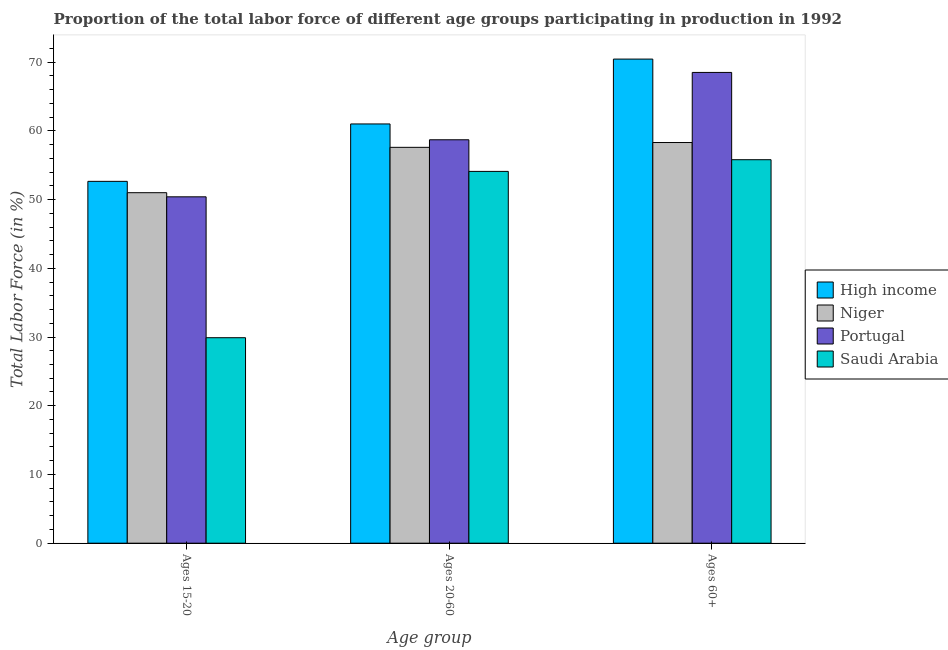How many groups of bars are there?
Keep it short and to the point. 3. How many bars are there on the 2nd tick from the right?
Your response must be concise. 4. What is the label of the 3rd group of bars from the left?
Provide a succinct answer. Ages 60+. What is the percentage of labor force above age 60 in Saudi Arabia?
Offer a terse response. 55.8. Across all countries, what is the maximum percentage of labor force within the age group 15-20?
Give a very brief answer. 52.65. Across all countries, what is the minimum percentage of labor force within the age group 20-60?
Your response must be concise. 54.1. In which country was the percentage of labor force within the age group 20-60 maximum?
Your response must be concise. High income. In which country was the percentage of labor force above age 60 minimum?
Offer a very short reply. Saudi Arabia. What is the total percentage of labor force within the age group 20-60 in the graph?
Offer a very short reply. 231.4. What is the difference between the percentage of labor force within the age group 20-60 in Portugal and that in Saudi Arabia?
Provide a succinct answer. 4.6. What is the difference between the percentage of labor force above age 60 in Saudi Arabia and the percentage of labor force within the age group 20-60 in Portugal?
Your answer should be very brief. -2.9. What is the average percentage of labor force within the age group 20-60 per country?
Offer a terse response. 57.85. What is the difference between the percentage of labor force within the age group 15-20 and percentage of labor force within the age group 20-60 in High income?
Make the answer very short. -8.35. What is the ratio of the percentage of labor force within the age group 15-20 in Niger to that in High income?
Provide a succinct answer. 0.97. Is the percentage of labor force within the age group 20-60 in Niger less than that in High income?
Offer a terse response. Yes. Is the difference between the percentage of labor force within the age group 20-60 in Saudi Arabia and Portugal greater than the difference between the percentage of labor force above age 60 in Saudi Arabia and Portugal?
Your response must be concise. Yes. What is the difference between the highest and the second highest percentage of labor force within the age group 15-20?
Make the answer very short. 1.65. What is the difference between the highest and the lowest percentage of labor force within the age group 15-20?
Offer a terse response. 22.75. Is the sum of the percentage of labor force within the age group 15-20 in Niger and Portugal greater than the maximum percentage of labor force above age 60 across all countries?
Ensure brevity in your answer.  Yes. What does the 1st bar from the left in Ages 20-60 represents?
Your answer should be very brief. High income. Are all the bars in the graph horizontal?
Keep it short and to the point. No. How many countries are there in the graph?
Provide a succinct answer. 4. Does the graph contain grids?
Provide a short and direct response. No. Where does the legend appear in the graph?
Offer a terse response. Center right. How many legend labels are there?
Offer a terse response. 4. What is the title of the graph?
Ensure brevity in your answer.  Proportion of the total labor force of different age groups participating in production in 1992. What is the label or title of the X-axis?
Provide a short and direct response. Age group. What is the Total Labor Force (in %) of High income in Ages 15-20?
Give a very brief answer. 52.65. What is the Total Labor Force (in %) in Portugal in Ages 15-20?
Offer a terse response. 50.4. What is the Total Labor Force (in %) of Saudi Arabia in Ages 15-20?
Provide a succinct answer. 29.9. What is the Total Labor Force (in %) in High income in Ages 20-60?
Provide a succinct answer. 61. What is the Total Labor Force (in %) of Niger in Ages 20-60?
Provide a succinct answer. 57.6. What is the Total Labor Force (in %) of Portugal in Ages 20-60?
Ensure brevity in your answer.  58.7. What is the Total Labor Force (in %) in Saudi Arabia in Ages 20-60?
Your answer should be compact. 54.1. What is the Total Labor Force (in %) of High income in Ages 60+?
Offer a very short reply. 70.44. What is the Total Labor Force (in %) of Niger in Ages 60+?
Your response must be concise. 58.3. What is the Total Labor Force (in %) of Portugal in Ages 60+?
Offer a terse response. 68.5. What is the Total Labor Force (in %) of Saudi Arabia in Ages 60+?
Keep it short and to the point. 55.8. Across all Age group, what is the maximum Total Labor Force (in %) in High income?
Your response must be concise. 70.44. Across all Age group, what is the maximum Total Labor Force (in %) of Niger?
Your answer should be very brief. 58.3. Across all Age group, what is the maximum Total Labor Force (in %) in Portugal?
Offer a terse response. 68.5. Across all Age group, what is the maximum Total Labor Force (in %) of Saudi Arabia?
Ensure brevity in your answer.  55.8. Across all Age group, what is the minimum Total Labor Force (in %) in High income?
Provide a short and direct response. 52.65. Across all Age group, what is the minimum Total Labor Force (in %) in Portugal?
Give a very brief answer. 50.4. Across all Age group, what is the minimum Total Labor Force (in %) in Saudi Arabia?
Ensure brevity in your answer.  29.9. What is the total Total Labor Force (in %) of High income in the graph?
Offer a very short reply. 184.09. What is the total Total Labor Force (in %) in Niger in the graph?
Your answer should be compact. 166.9. What is the total Total Labor Force (in %) of Portugal in the graph?
Your answer should be compact. 177.6. What is the total Total Labor Force (in %) of Saudi Arabia in the graph?
Give a very brief answer. 139.8. What is the difference between the Total Labor Force (in %) of High income in Ages 15-20 and that in Ages 20-60?
Offer a very short reply. -8.35. What is the difference between the Total Labor Force (in %) in Niger in Ages 15-20 and that in Ages 20-60?
Provide a short and direct response. -6.6. What is the difference between the Total Labor Force (in %) of Portugal in Ages 15-20 and that in Ages 20-60?
Ensure brevity in your answer.  -8.3. What is the difference between the Total Labor Force (in %) of Saudi Arabia in Ages 15-20 and that in Ages 20-60?
Your answer should be very brief. -24.2. What is the difference between the Total Labor Force (in %) of High income in Ages 15-20 and that in Ages 60+?
Ensure brevity in your answer.  -17.79. What is the difference between the Total Labor Force (in %) in Niger in Ages 15-20 and that in Ages 60+?
Provide a succinct answer. -7.3. What is the difference between the Total Labor Force (in %) in Portugal in Ages 15-20 and that in Ages 60+?
Your answer should be compact. -18.1. What is the difference between the Total Labor Force (in %) in Saudi Arabia in Ages 15-20 and that in Ages 60+?
Offer a terse response. -25.9. What is the difference between the Total Labor Force (in %) in High income in Ages 20-60 and that in Ages 60+?
Your answer should be very brief. -9.44. What is the difference between the Total Labor Force (in %) of Niger in Ages 20-60 and that in Ages 60+?
Offer a very short reply. -0.7. What is the difference between the Total Labor Force (in %) in Portugal in Ages 20-60 and that in Ages 60+?
Provide a short and direct response. -9.8. What is the difference between the Total Labor Force (in %) of High income in Ages 15-20 and the Total Labor Force (in %) of Niger in Ages 20-60?
Your response must be concise. -4.95. What is the difference between the Total Labor Force (in %) in High income in Ages 15-20 and the Total Labor Force (in %) in Portugal in Ages 20-60?
Your response must be concise. -6.05. What is the difference between the Total Labor Force (in %) of High income in Ages 15-20 and the Total Labor Force (in %) of Saudi Arabia in Ages 20-60?
Ensure brevity in your answer.  -1.45. What is the difference between the Total Labor Force (in %) of Niger in Ages 15-20 and the Total Labor Force (in %) of Portugal in Ages 20-60?
Your answer should be compact. -7.7. What is the difference between the Total Labor Force (in %) in Portugal in Ages 15-20 and the Total Labor Force (in %) in Saudi Arabia in Ages 20-60?
Your response must be concise. -3.7. What is the difference between the Total Labor Force (in %) in High income in Ages 15-20 and the Total Labor Force (in %) in Niger in Ages 60+?
Give a very brief answer. -5.65. What is the difference between the Total Labor Force (in %) of High income in Ages 15-20 and the Total Labor Force (in %) of Portugal in Ages 60+?
Provide a short and direct response. -15.85. What is the difference between the Total Labor Force (in %) of High income in Ages 15-20 and the Total Labor Force (in %) of Saudi Arabia in Ages 60+?
Offer a terse response. -3.15. What is the difference between the Total Labor Force (in %) in Niger in Ages 15-20 and the Total Labor Force (in %) in Portugal in Ages 60+?
Keep it short and to the point. -17.5. What is the difference between the Total Labor Force (in %) of Niger in Ages 15-20 and the Total Labor Force (in %) of Saudi Arabia in Ages 60+?
Offer a very short reply. -4.8. What is the difference between the Total Labor Force (in %) in High income in Ages 20-60 and the Total Labor Force (in %) in Niger in Ages 60+?
Your answer should be compact. 2.7. What is the difference between the Total Labor Force (in %) in High income in Ages 20-60 and the Total Labor Force (in %) in Portugal in Ages 60+?
Your response must be concise. -7.5. What is the difference between the Total Labor Force (in %) in High income in Ages 20-60 and the Total Labor Force (in %) in Saudi Arabia in Ages 60+?
Ensure brevity in your answer.  5.2. What is the difference between the Total Labor Force (in %) in Niger in Ages 20-60 and the Total Labor Force (in %) in Portugal in Ages 60+?
Offer a very short reply. -10.9. What is the difference between the Total Labor Force (in %) in Portugal in Ages 20-60 and the Total Labor Force (in %) in Saudi Arabia in Ages 60+?
Your response must be concise. 2.9. What is the average Total Labor Force (in %) of High income per Age group?
Offer a terse response. 61.36. What is the average Total Labor Force (in %) in Niger per Age group?
Give a very brief answer. 55.63. What is the average Total Labor Force (in %) of Portugal per Age group?
Provide a short and direct response. 59.2. What is the average Total Labor Force (in %) of Saudi Arabia per Age group?
Make the answer very short. 46.6. What is the difference between the Total Labor Force (in %) in High income and Total Labor Force (in %) in Niger in Ages 15-20?
Your answer should be compact. 1.65. What is the difference between the Total Labor Force (in %) of High income and Total Labor Force (in %) of Portugal in Ages 15-20?
Keep it short and to the point. 2.25. What is the difference between the Total Labor Force (in %) in High income and Total Labor Force (in %) in Saudi Arabia in Ages 15-20?
Your response must be concise. 22.75. What is the difference between the Total Labor Force (in %) of Niger and Total Labor Force (in %) of Saudi Arabia in Ages 15-20?
Make the answer very short. 21.1. What is the difference between the Total Labor Force (in %) in Portugal and Total Labor Force (in %) in Saudi Arabia in Ages 15-20?
Offer a very short reply. 20.5. What is the difference between the Total Labor Force (in %) of High income and Total Labor Force (in %) of Niger in Ages 20-60?
Offer a terse response. 3.4. What is the difference between the Total Labor Force (in %) of High income and Total Labor Force (in %) of Portugal in Ages 20-60?
Your answer should be compact. 2.3. What is the difference between the Total Labor Force (in %) in High income and Total Labor Force (in %) in Saudi Arabia in Ages 20-60?
Keep it short and to the point. 6.9. What is the difference between the Total Labor Force (in %) in Niger and Total Labor Force (in %) in Portugal in Ages 20-60?
Your answer should be compact. -1.1. What is the difference between the Total Labor Force (in %) in Niger and Total Labor Force (in %) in Saudi Arabia in Ages 20-60?
Offer a terse response. 3.5. What is the difference between the Total Labor Force (in %) of Portugal and Total Labor Force (in %) of Saudi Arabia in Ages 20-60?
Keep it short and to the point. 4.6. What is the difference between the Total Labor Force (in %) in High income and Total Labor Force (in %) in Niger in Ages 60+?
Your answer should be compact. 12.14. What is the difference between the Total Labor Force (in %) of High income and Total Labor Force (in %) of Portugal in Ages 60+?
Your response must be concise. 1.94. What is the difference between the Total Labor Force (in %) in High income and Total Labor Force (in %) in Saudi Arabia in Ages 60+?
Provide a succinct answer. 14.64. What is the difference between the Total Labor Force (in %) in Portugal and Total Labor Force (in %) in Saudi Arabia in Ages 60+?
Your answer should be compact. 12.7. What is the ratio of the Total Labor Force (in %) of High income in Ages 15-20 to that in Ages 20-60?
Offer a terse response. 0.86. What is the ratio of the Total Labor Force (in %) in Niger in Ages 15-20 to that in Ages 20-60?
Your answer should be compact. 0.89. What is the ratio of the Total Labor Force (in %) in Portugal in Ages 15-20 to that in Ages 20-60?
Offer a terse response. 0.86. What is the ratio of the Total Labor Force (in %) of Saudi Arabia in Ages 15-20 to that in Ages 20-60?
Your response must be concise. 0.55. What is the ratio of the Total Labor Force (in %) of High income in Ages 15-20 to that in Ages 60+?
Your answer should be very brief. 0.75. What is the ratio of the Total Labor Force (in %) in Niger in Ages 15-20 to that in Ages 60+?
Ensure brevity in your answer.  0.87. What is the ratio of the Total Labor Force (in %) of Portugal in Ages 15-20 to that in Ages 60+?
Keep it short and to the point. 0.74. What is the ratio of the Total Labor Force (in %) of Saudi Arabia in Ages 15-20 to that in Ages 60+?
Ensure brevity in your answer.  0.54. What is the ratio of the Total Labor Force (in %) of High income in Ages 20-60 to that in Ages 60+?
Provide a short and direct response. 0.87. What is the ratio of the Total Labor Force (in %) in Niger in Ages 20-60 to that in Ages 60+?
Your answer should be compact. 0.99. What is the ratio of the Total Labor Force (in %) in Portugal in Ages 20-60 to that in Ages 60+?
Your answer should be compact. 0.86. What is the ratio of the Total Labor Force (in %) in Saudi Arabia in Ages 20-60 to that in Ages 60+?
Make the answer very short. 0.97. What is the difference between the highest and the second highest Total Labor Force (in %) in High income?
Offer a very short reply. 9.44. What is the difference between the highest and the lowest Total Labor Force (in %) of High income?
Your response must be concise. 17.79. What is the difference between the highest and the lowest Total Labor Force (in %) in Niger?
Your answer should be very brief. 7.3. What is the difference between the highest and the lowest Total Labor Force (in %) of Saudi Arabia?
Ensure brevity in your answer.  25.9. 